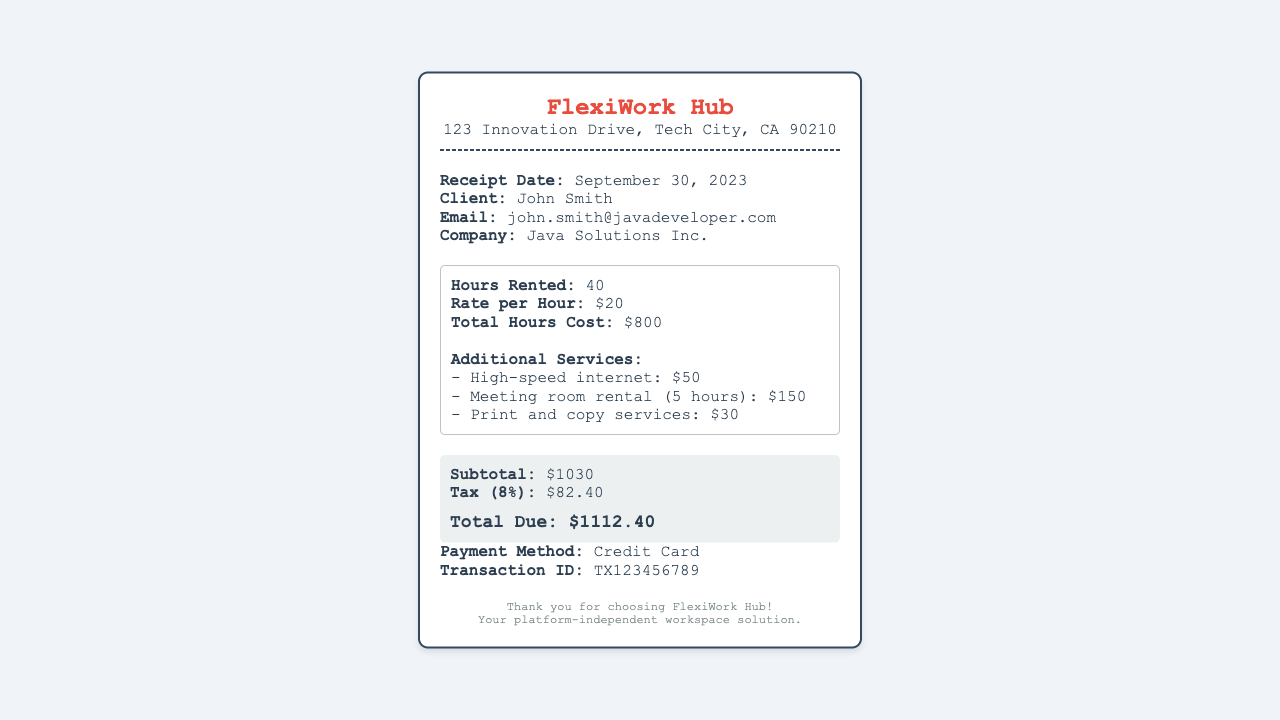What is the receipt date? The receipt date is explicitly mentioned in the document, which is September 30, 2023.
Answer: September 30, 2023 Who is the client? The document provides the name of the client as John Smith.
Answer: John Smith How many hours were rented? The total hours rented are specified as 40 in the document.
Answer: 40 What is the rate per hour? The document states the rate per hour is $20.
Answer: $20 What is the subtotal amount? The subtotal is clearly listed in the document as $1030.
Answer: $1030 What are the additional services utilized? The document lists three additional services provided: high-speed internet, meeting room rental, and print and copy services.
Answer: High-speed internet, meeting room rental, print and copy services What is the total due? The total due amount, including tax, is specified as $1112.40 in the document.
Answer: $1112.40 What payment method was used? The document specifies that the payment method used was a credit card.
Answer: Credit Card What is the tax percentage applied? The tax percentage mentioned in the document is 8%.
Answer: 8% 